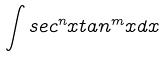<formula> <loc_0><loc_0><loc_500><loc_500>\int s e c ^ { n } x t a n ^ { m } x d x</formula> 